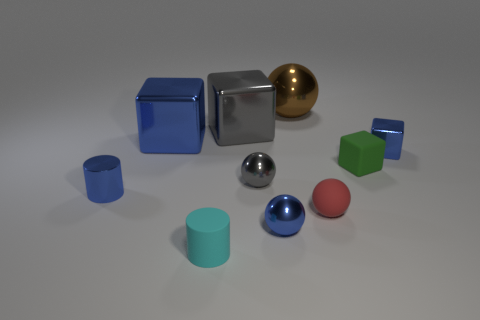Subtract all tiny gray spheres. How many spheres are left? 3 Subtract all gray cubes. How many cubes are left? 3 Subtract all balls. How many objects are left? 6 Subtract 4 balls. How many balls are left? 0 Subtract all gray cylinders. How many blue cubes are left? 2 Add 3 big blue cubes. How many big blue cubes exist? 4 Subtract 1 blue cylinders. How many objects are left? 9 Subtract all blue cylinders. Subtract all brown blocks. How many cylinders are left? 1 Subtract all large red things. Subtract all green objects. How many objects are left? 9 Add 5 large blue things. How many large blue things are left? 6 